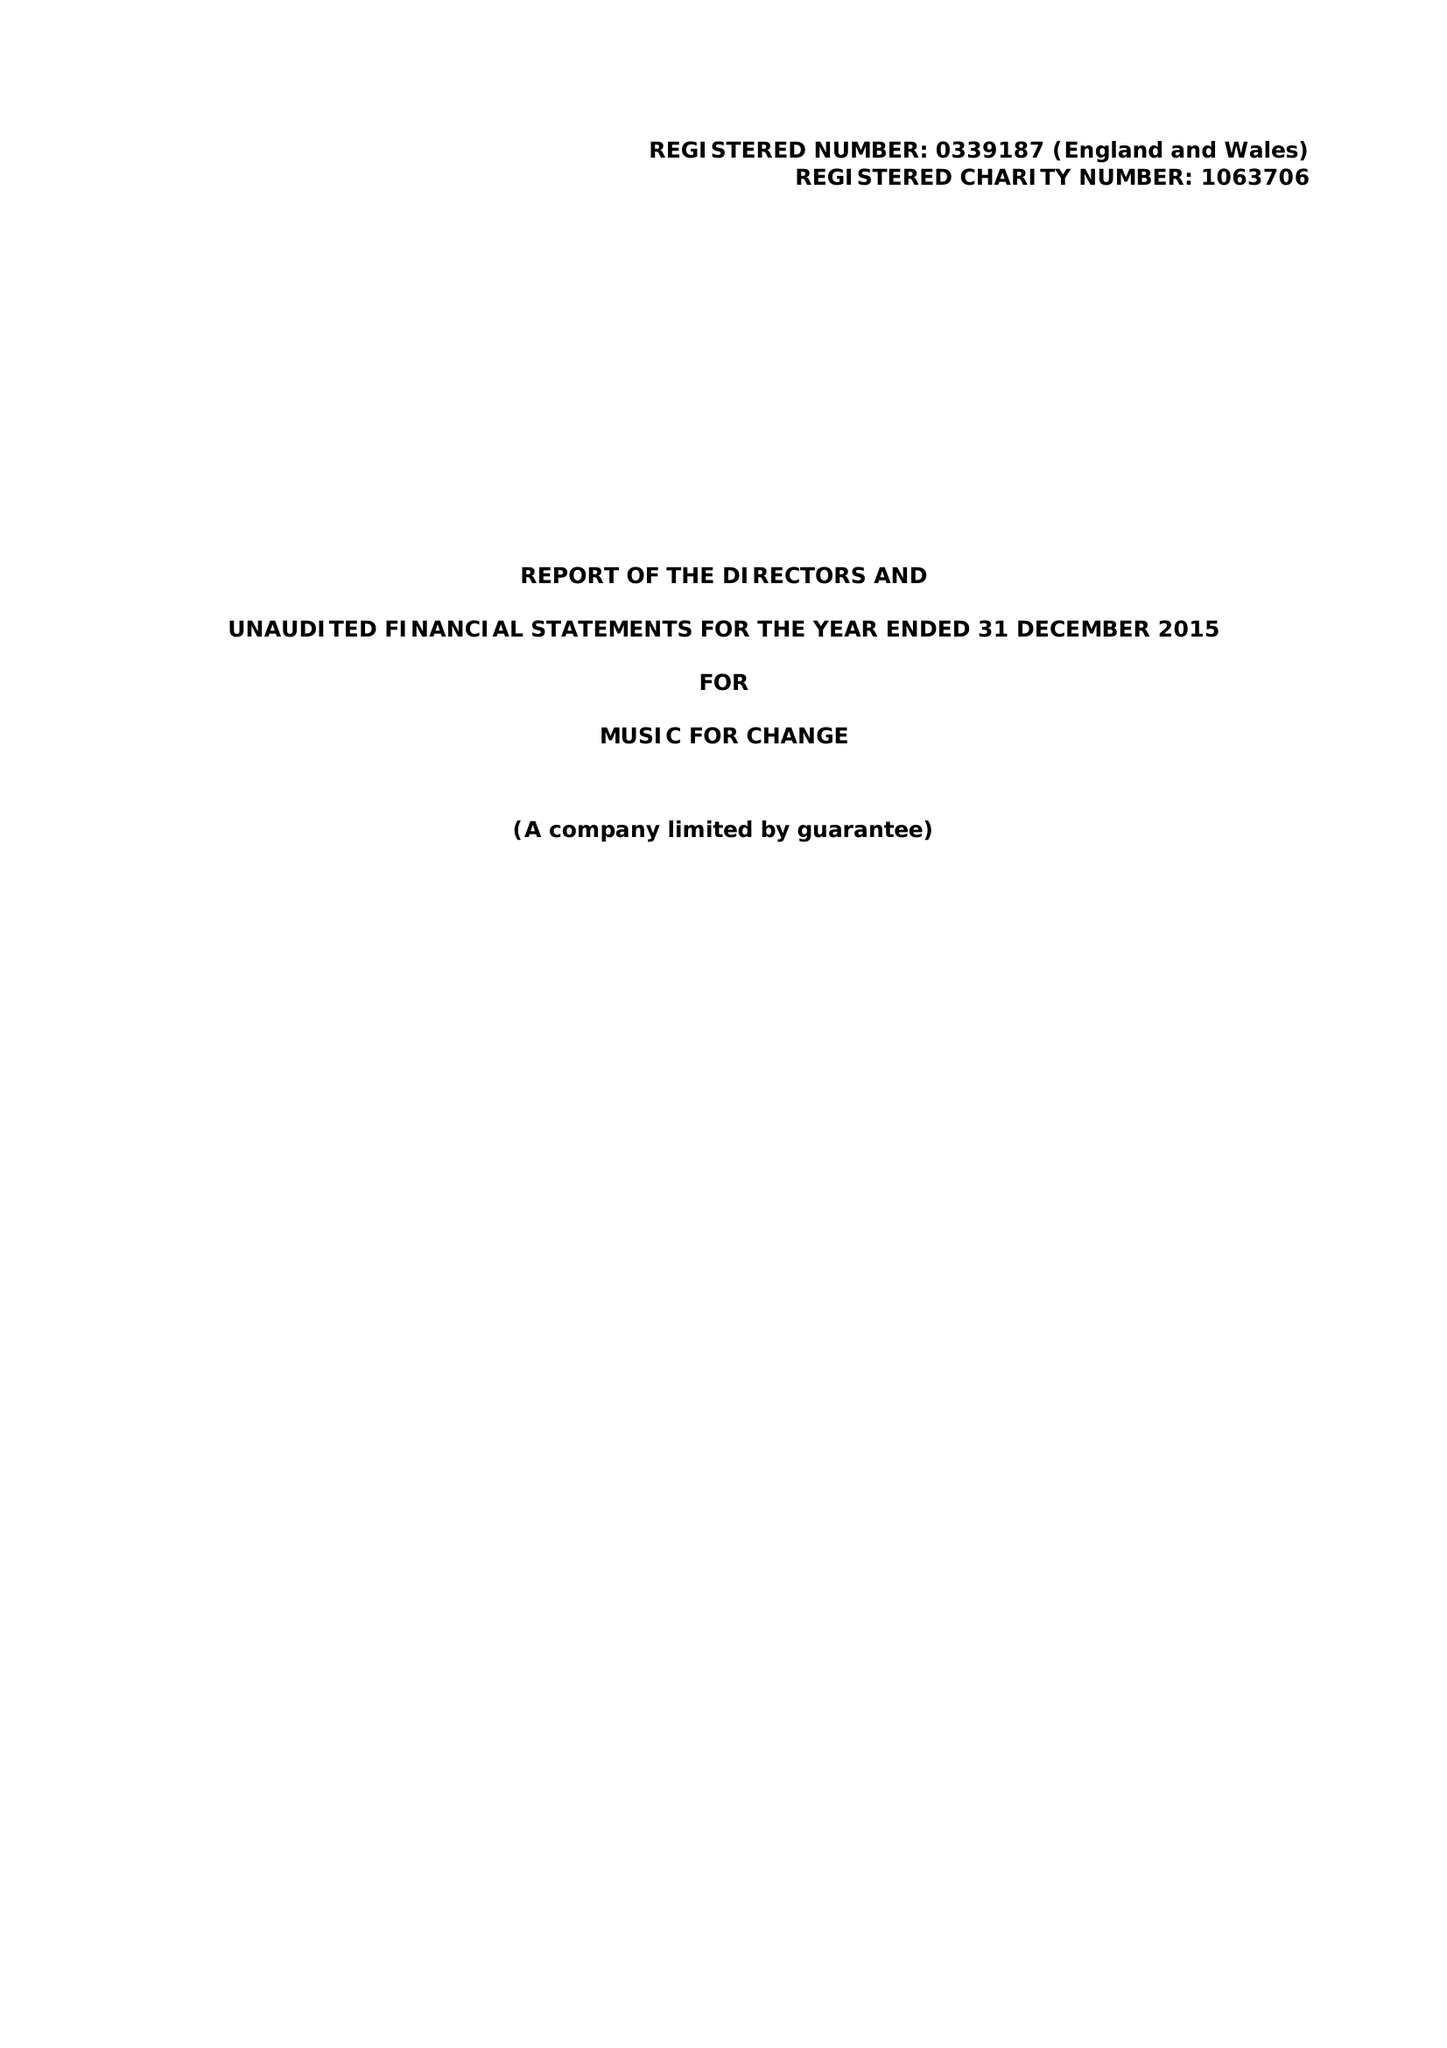What is the value for the address__post_town?
Answer the question using a single word or phrase. CANTERBURY 